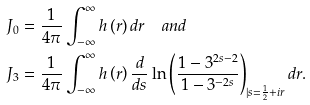<formula> <loc_0><loc_0><loc_500><loc_500>J _ { 0 } & = \frac { 1 } { 4 \pi } \int _ { - \infty } ^ { \infty } h \left ( r \right ) d r \quad a n d \\ J _ { 3 } & = \frac { 1 } { 4 \pi } \int _ { - \infty } ^ { \infty } h \left ( r \right ) \frac { d } { d s } \ln \left ( \frac { 1 - 3 ^ { 2 s - 2 } } { 1 - 3 ^ { - 2 s } } \right ) _ { | s = \frac { 1 } { 2 } + i r } d r .</formula> 